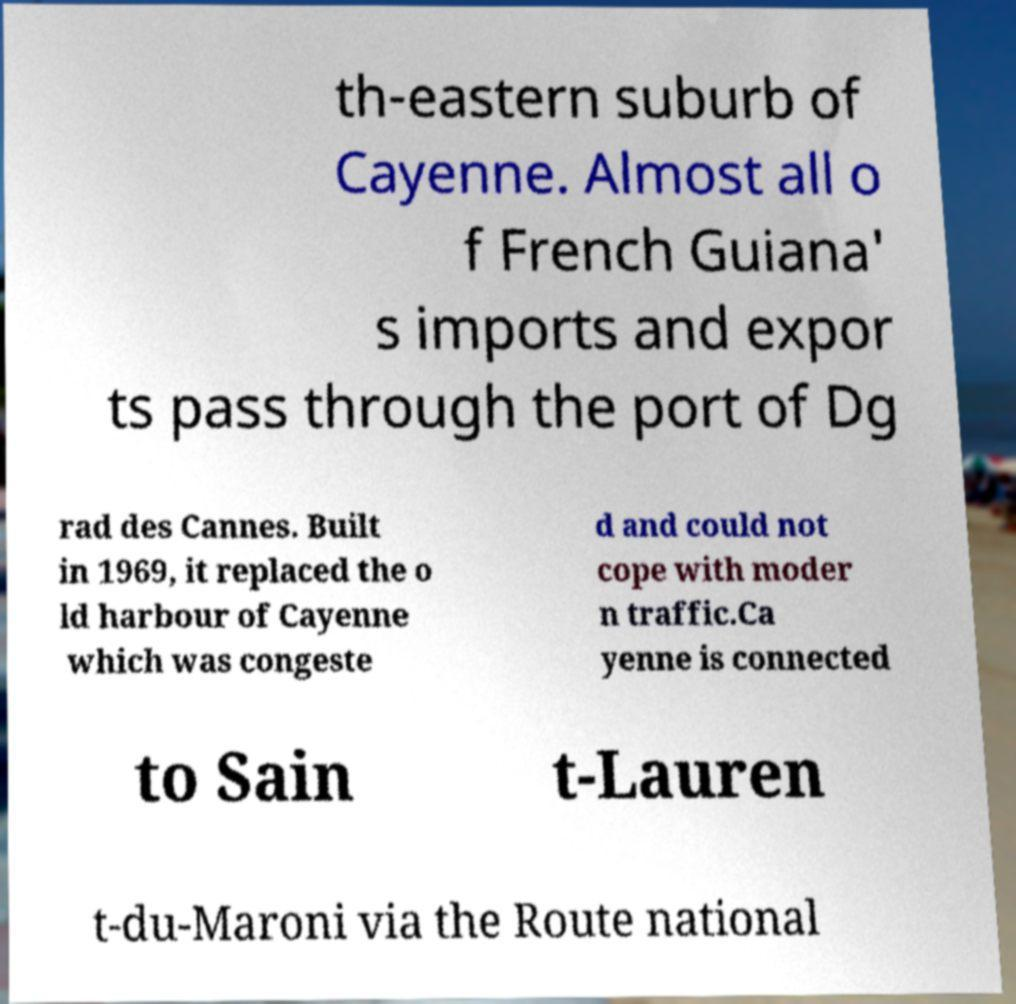Could you assist in decoding the text presented in this image and type it out clearly? th-eastern suburb of Cayenne. Almost all o f French Guiana' s imports and expor ts pass through the port of Dg rad des Cannes. Built in 1969, it replaced the o ld harbour of Cayenne which was congeste d and could not cope with moder n traffic.Ca yenne is connected to Sain t-Lauren t-du-Maroni via the Route national 